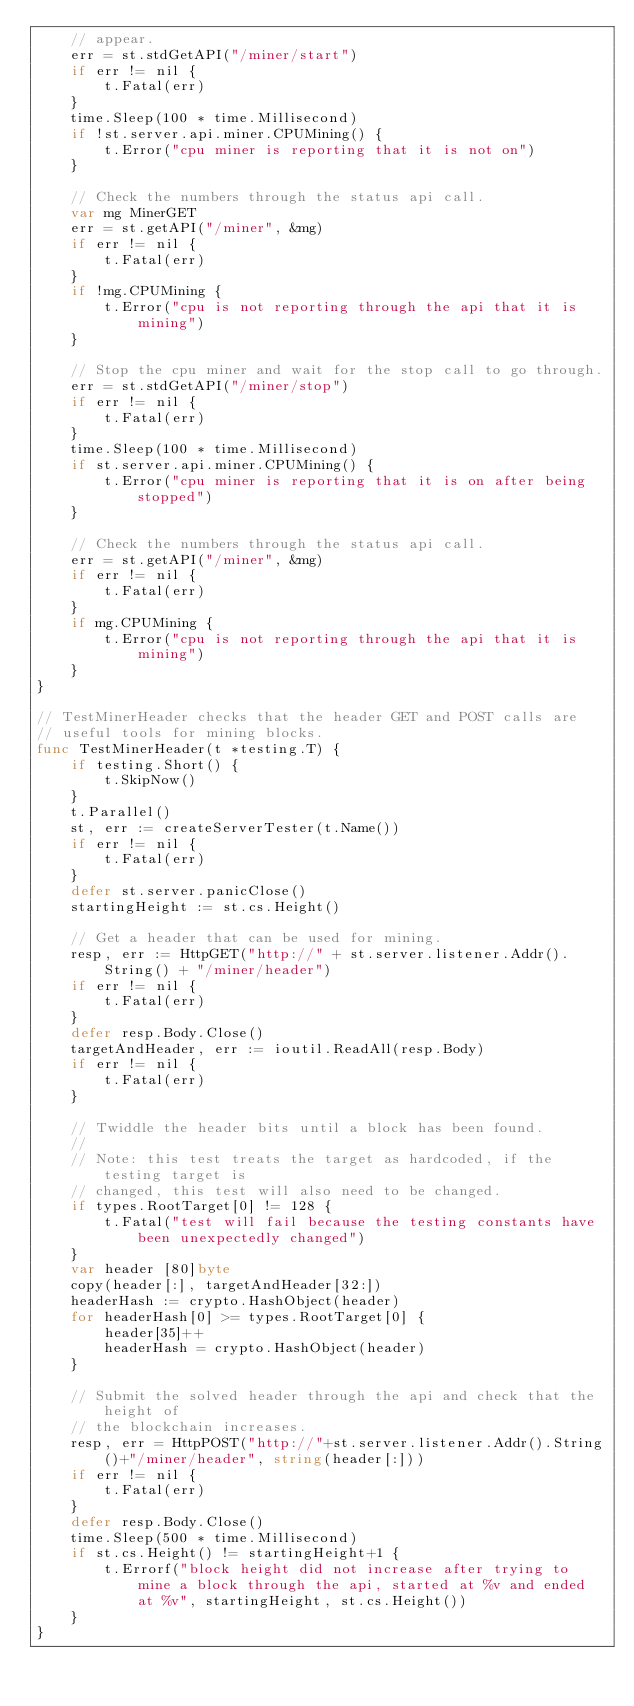<code> <loc_0><loc_0><loc_500><loc_500><_Go_>	// appear.
	err = st.stdGetAPI("/miner/start")
	if err != nil {
		t.Fatal(err)
	}
	time.Sleep(100 * time.Millisecond)
	if !st.server.api.miner.CPUMining() {
		t.Error("cpu miner is reporting that it is not on")
	}

	// Check the numbers through the status api call.
	var mg MinerGET
	err = st.getAPI("/miner", &mg)
	if err != nil {
		t.Fatal(err)
	}
	if !mg.CPUMining {
		t.Error("cpu is not reporting through the api that it is mining")
	}

	// Stop the cpu miner and wait for the stop call to go through.
	err = st.stdGetAPI("/miner/stop")
	if err != nil {
		t.Fatal(err)
	}
	time.Sleep(100 * time.Millisecond)
	if st.server.api.miner.CPUMining() {
		t.Error("cpu miner is reporting that it is on after being stopped")
	}

	// Check the numbers through the status api call.
	err = st.getAPI("/miner", &mg)
	if err != nil {
		t.Fatal(err)
	}
	if mg.CPUMining {
		t.Error("cpu is not reporting through the api that it is mining")
	}
}

// TestMinerHeader checks that the header GET and POST calls are
// useful tools for mining blocks.
func TestMinerHeader(t *testing.T) {
	if testing.Short() {
		t.SkipNow()
	}
	t.Parallel()
	st, err := createServerTester(t.Name())
	if err != nil {
		t.Fatal(err)
	}
	defer st.server.panicClose()
	startingHeight := st.cs.Height()

	// Get a header that can be used for mining.
	resp, err := HttpGET("http://" + st.server.listener.Addr().String() + "/miner/header")
	if err != nil {
		t.Fatal(err)
	}
	defer resp.Body.Close()
	targetAndHeader, err := ioutil.ReadAll(resp.Body)
	if err != nil {
		t.Fatal(err)
	}

	// Twiddle the header bits until a block has been found.
	//
	// Note: this test treats the target as hardcoded, if the testing target is
	// changed, this test will also need to be changed.
	if types.RootTarget[0] != 128 {
		t.Fatal("test will fail because the testing constants have been unexpectedly changed")
	}
	var header [80]byte
	copy(header[:], targetAndHeader[32:])
	headerHash := crypto.HashObject(header)
	for headerHash[0] >= types.RootTarget[0] {
		header[35]++
		headerHash = crypto.HashObject(header)
	}

	// Submit the solved header through the api and check that the height of
	// the blockchain increases.
	resp, err = HttpPOST("http://"+st.server.listener.Addr().String()+"/miner/header", string(header[:]))
	if err != nil {
		t.Fatal(err)
	}
	defer resp.Body.Close()
	time.Sleep(500 * time.Millisecond)
	if st.cs.Height() != startingHeight+1 {
		t.Errorf("block height did not increase after trying to mine a block through the api, started at %v and ended at %v", startingHeight, st.cs.Height())
	}
}
</code> 